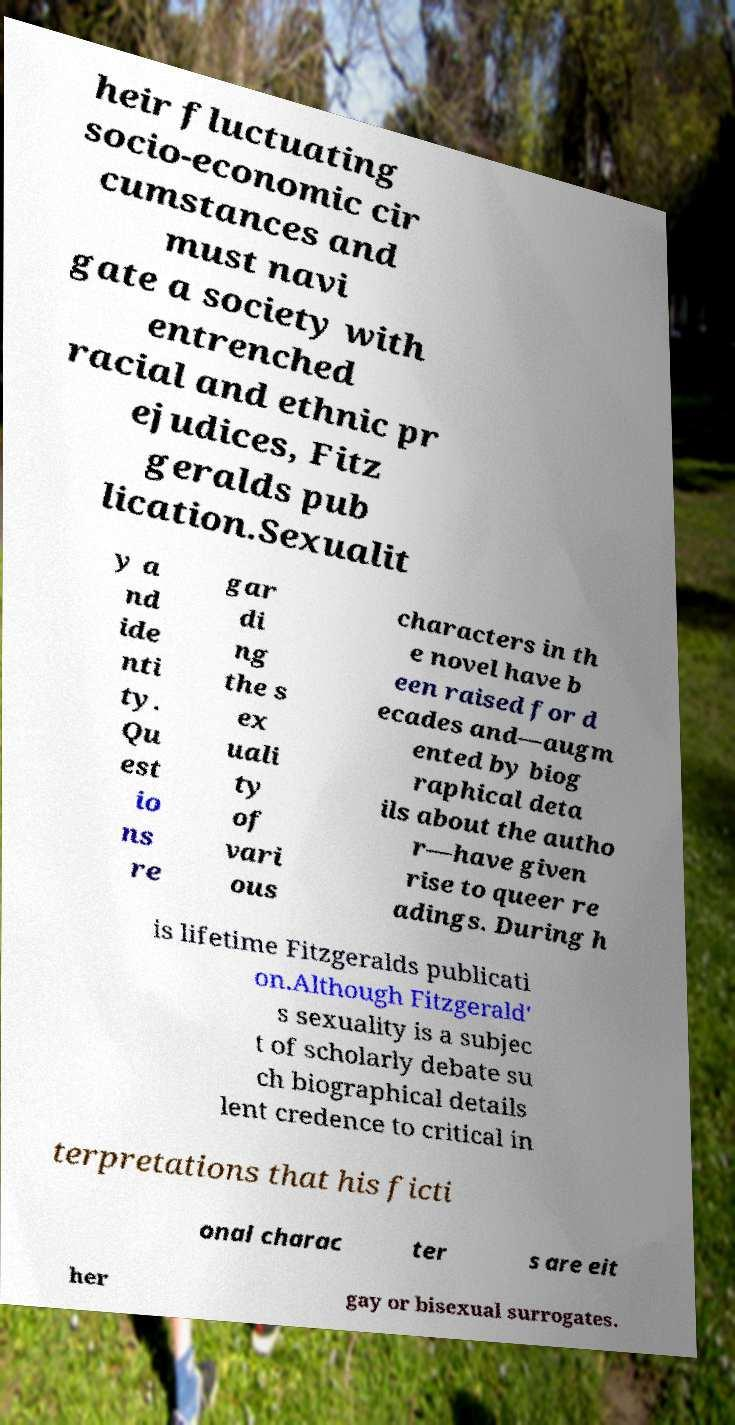Please identify and transcribe the text found in this image. heir fluctuating socio-economic cir cumstances and must navi gate a society with entrenched racial and ethnic pr ejudices, Fitz geralds pub lication.Sexualit y a nd ide nti ty. Qu est io ns re gar di ng the s ex uali ty of vari ous characters in th e novel have b een raised for d ecades and—augm ented by biog raphical deta ils about the autho r—have given rise to queer re adings. During h is lifetime Fitzgeralds publicati on.Although Fitzgerald' s sexuality is a subjec t of scholarly debate su ch biographical details lent credence to critical in terpretations that his ficti onal charac ter s are eit her gay or bisexual surrogates. 